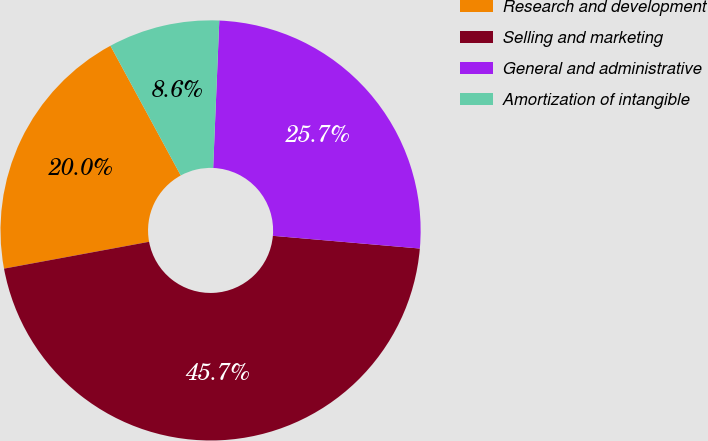Convert chart. <chart><loc_0><loc_0><loc_500><loc_500><pie_chart><fcel>Research and development<fcel>Selling and marketing<fcel>General and administrative<fcel>Amortization of intangible<nl><fcel>20.0%<fcel>45.71%<fcel>25.71%<fcel>8.57%<nl></chart> 